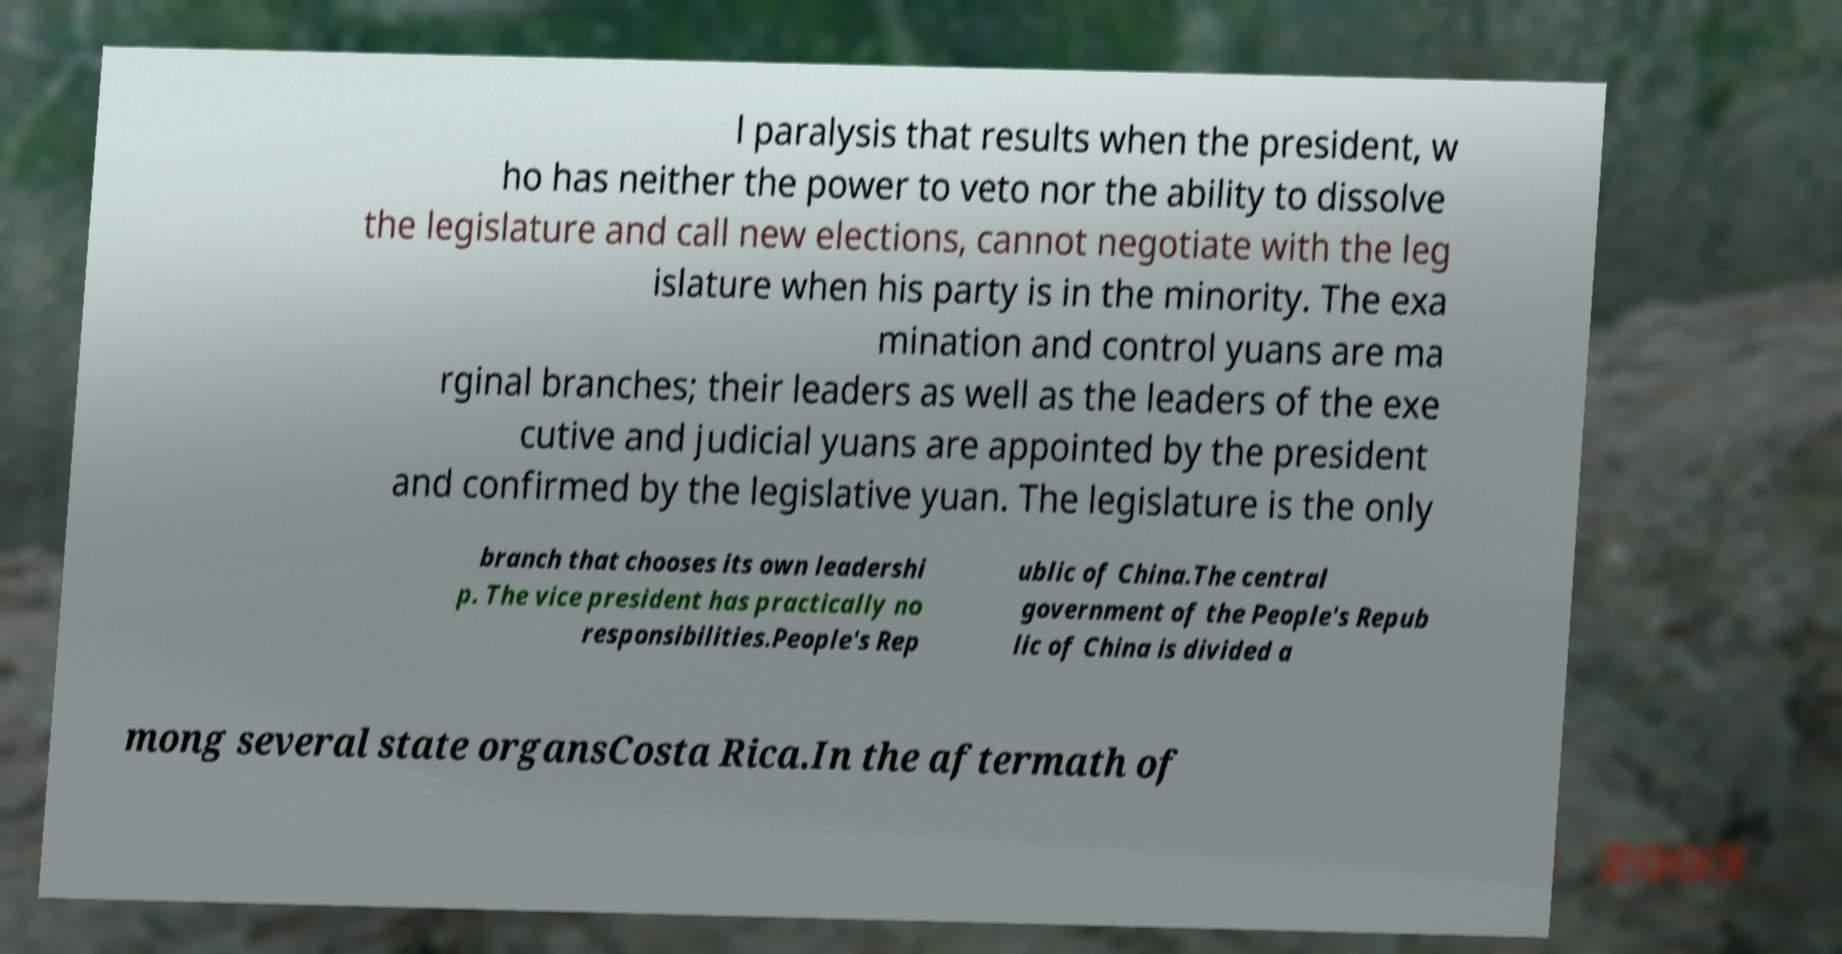Can you accurately transcribe the text from the provided image for me? l paralysis that results when the president, w ho has neither the power to veto nor the ability to dissolve the legislature and call new elections, cannot negotiate with the leg islature when his party is in the minority. The exa mination and control yuans are ma rginal branches; their leaders as well as the leaders of the exe cutive and judicial yuans are appointed by the president and confirmed by the legislative yuan. The legislature is the only branch that chooses its own leadershi p. The vice president has practically no responsibilities.People's Rep ublic of China.The central government of the People's Repub lic of China is divided a mong several state organsCosta Rica.In the aftermath of 